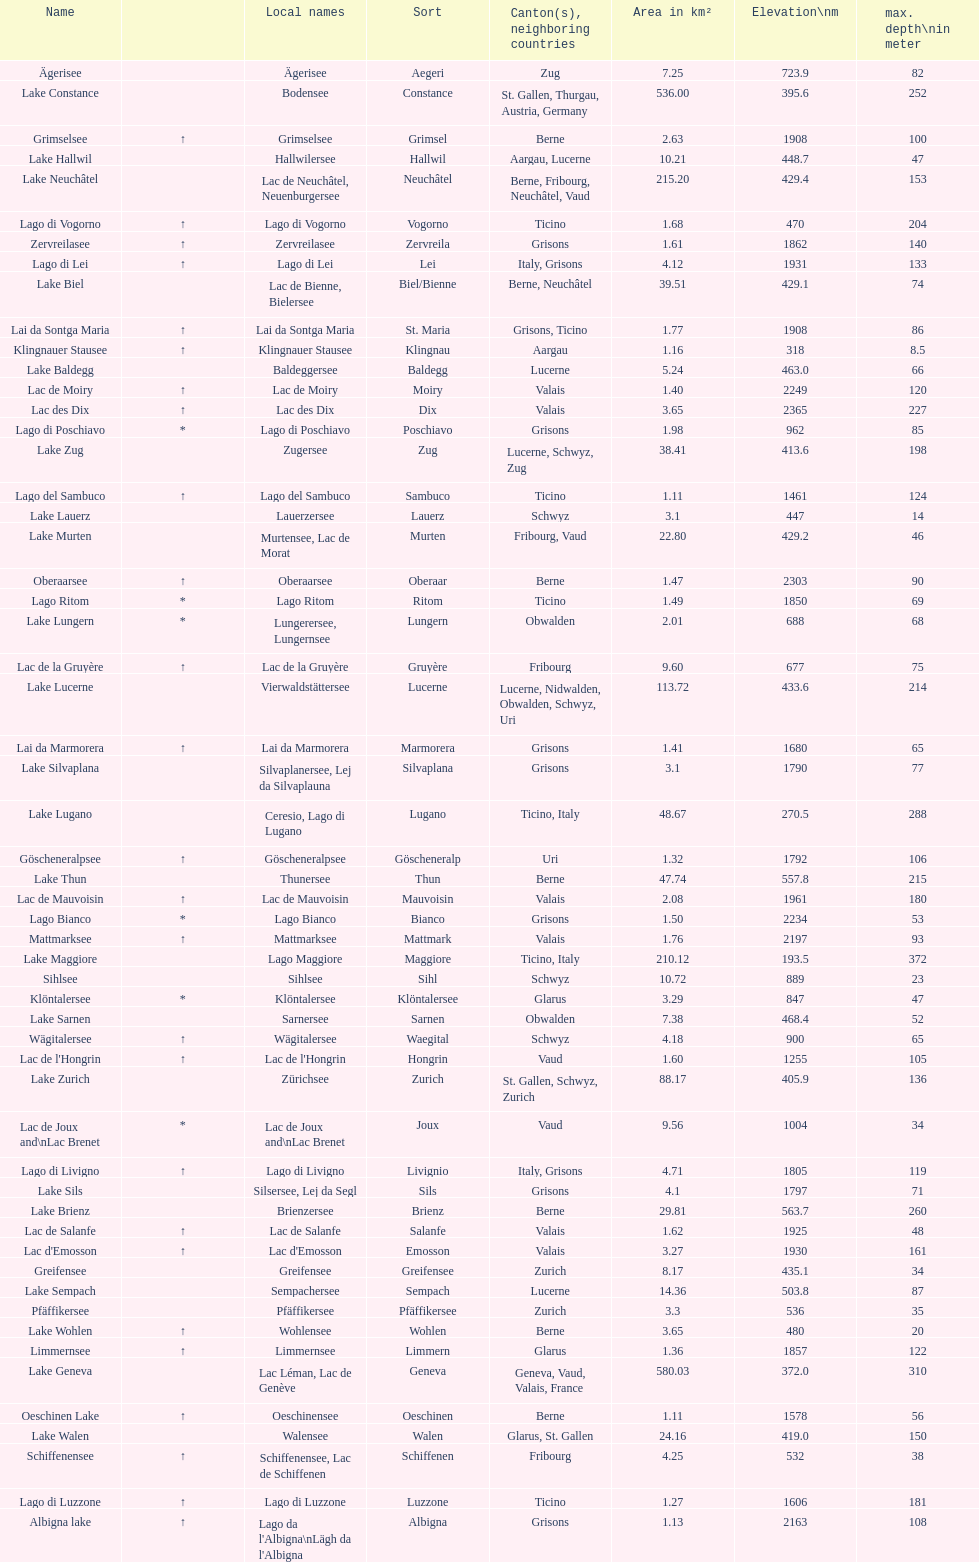At the highest elevation, which lake can be found? Lac des Dix. 